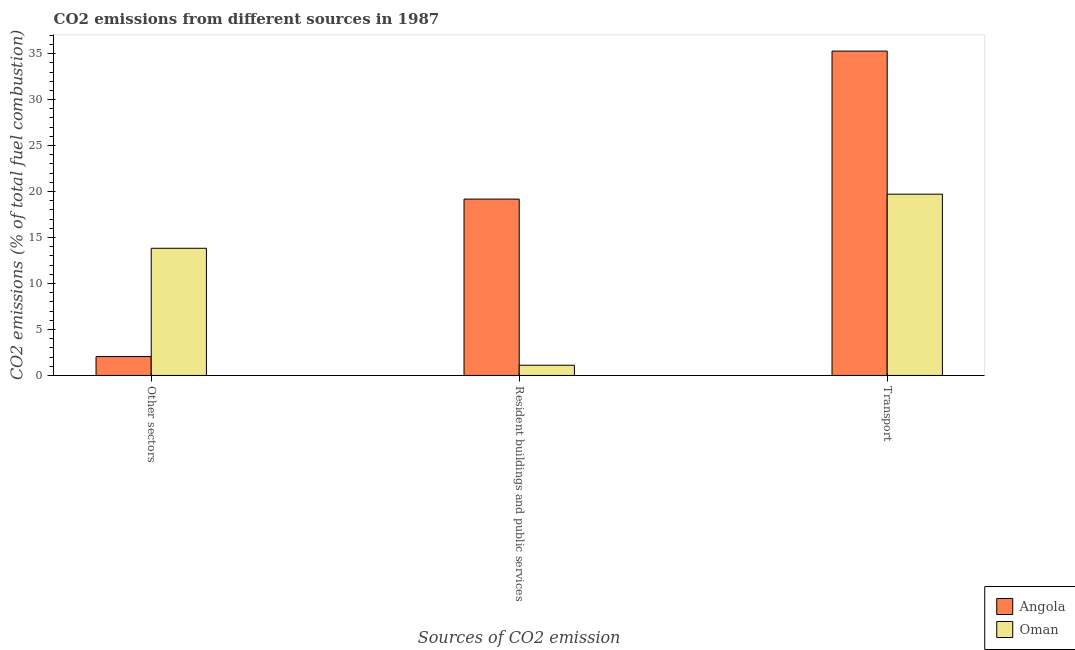How many different coloured bars are there?
Provide a succinct answer. 2. How many groups of bars are there?
Your response must be concise. 3. Are the number of bars on each tick of the X-axis equal?
Make the answer very short. Yes. What is the label of the 1st group of bars from the left?
Provide a succinct answer. Other sectors. What is the percentage of co2 emissions from resident buildings and public services in Angola?
Provide a succinct answer. 19.18. Across all countries, what is the maximum percentage of co2 emissions from transport?
Give a very brief answer. 35.27. Across all countries, what is the minimum percentage of co2 emissions from resident buildings and public services?
Your answer should be very brief. 1.11. In which country was the percentage of co2 emissions from resident buildings and public services maximum?
Ensure brevity in your answer.  Angola. In which country was the percentage of co2 emissions from other sectors minimum?
Your response must be concise. Angola. What is the total percentage of co2 emissions from other sectors in the graph?
Offer a terse response. 15.89. What is the difference between the percentage of co2 emissions from other sectors in Oman and that in Angola?
Keep it short and to the point. 11.78. What is the difference between the percentage of co2 emissions from other sectors in Angola and the percentage of co2 emissions from resident buildings and public services in Oman?
Give a very brief answer. 0.94. What is the average percentage of co2 emissions from transport per country?
Give a very brief answer. 27.49. What is the difference between the percentage of co2 emissions from transport and percentage of co2 emissions from other sectors in Oman?
Your answer should be compact. 5.88. In how many countries, is the percentage of co2 emissions from other sectors greater than 15 %?
Your answer should be very brief. 0. What is the ratio of the percentage of co2 emissions from resident buildings and public services in Oman to that in Angola?
Give a very brief answer. 0.06. What is the difference between the highest and the second highest percentage of co2 emissions from resident buildings and public services?
Provide a succinct answer. 18.07. What is the difference between the highest and the lowest percentage of co2 emissions from transport?
Ensure brevity in your answer.  15.56. What does the 2nd bar from the left in Resident buildings and public services represents?
Provide a short and direct response. Oman. What does the 2nd bar from the right in Transport represents?
Ensure brevity in your answer.  Angola. What is the difference between two consecutive major ticks on the Y-axis?
Give a very brief answer. 5. Are the values on the major ticks of Y-axis written in scientific E-notation?
Provide a succinct answer. No. How many legend labels are there?
Keep it short and to the point. 2. What is the title of the graph?
Provide a succinct answer. CO2 emissions from different sources in 1987. What is the label or title of the X-axis?
Your answer should be very brief. Sources of CO2 emission. What is the label or title of the Y-axis?
Your answer should be very brief. CO2 emissions (% of total fuel combustion). What is the CO2 emissions (% of total fuel combustion) in Angola in Other sectors?
Make the answer very short. 2.05. What is the CO2 emissions (% of total fuel combustion) in Oman in Other sectors?
Keep it short and to the point. 13.83. What is the CO2 emissions (% of total fuel combustion) in Angola in Resident buildings and public services?
Make the answer very short. 19.18. What is the CO2 emissions (% of total fuel combustion) in Oman in Resident buildings and public services?
Provide a succinct answer. 1.11. What is the CO2 emissions (% of total fuel combustion) in Angola in Transport?
Offer a terse response. 35.27. What is the CO2 emissions (% of total fuel combustion) in Oman in Transport?
Your response must be concise. 19.71. Across all Sources of CO2 emission, what is the maximum CO2 emissions (% of total fuel combustion) of Angola?
Give a very brief answer. 35.27. Across all Sources of CO2 emission, what is the maximum CO2 emissions (% of total fuel combustion) of Oman?
Keep it short and to the point. 19.71. Across all Sources of CO2 emission, what is the minimum CO2 emissions (% of total fuel combustion) in Angola?
Offer a very short reply. 2.05. Across all Sources of CO2 emission, what is the minimum CO2 emissions (% of total fuel combustion) of Oman?
Provide a succinct answer. 1.11. What is the total CO2 emissions (% of total fuel combustion) of Angola in the graph?
Keep it short and to the point. 56.51. What is the total CO2 emissions (% of total fuel combustion) in Oman in the graph?
Your response must be concise. 34.66. What is the difference between the CO2 emissions (% of total fuel combustion) in Angola in Other sectors and that in Resident buildings and public services?
Give a very brief answer. -17.12. What is the difference between the CO2 emissions (% of total fuel combustion) in Oman in Other sectors and that in Resident buildings and public services?
Provide a succinct answer. 12.72. What is the difference between the CO2 emissions (% of total fuel combustion) of Angola in Other sectors and that in Transport?
Your response must be concise. -33.22. What is the difference between the CO2 emissions (% of total fuel combustion) in Oman in Other sectors and that in Transport?
Make the answer very short. -5.88. What is the difference between the CO2 emissions (% of total fuel combustion) in Angola in Resident buildings and public services and that in Transport?
Offer a terse response. -16.1. What is the difference between the CO2 emissions (% of total fuel combustion) in Oman in Resident buildings and public services and that in Transport?
Your answer should be compact. -18.6. What is the difference between the CO2 emissions (% of total fuel combustion) in Angola in Other sectors and the CO2 emissions (% of total fuel combustion) in Oman in Resident buildings and public services?
Your answer should be very brief. 0.94. What is the difference between the CO2 emissions (% of total fuel combustion) of Angola in Other sectors and the CO2 emissions (% of total fuel combustion) of Oman in Transport?
Your answer should be very brief. -17.66. What is the difference between the CO2 emissions (% of total fuel combustion) of Angola in Resident buildings and public services and the CO2 emissions (% of total fuel combustion) of Oman in Transport?
Provide a succinct answer. -0.54. What is the average CO2 emissions (% of total fuel combustion) in Angola per Sources of CO2 emission?
Your answer should be compact. 18.84. What is the average CO2 emissions (% of total fuel combustion) in Oman per Sources of CO2 emission?
Offer a very short reply. 11.55. What is the difference between the CO2 emissions (% of total fuel combustion) of Angola and CO2 emissions (% of total fuel combustion) of Oman in Other sectors?
Ensure brevity in your answer.  -11.78. What is the difference between the CO2 emissions (% of total fuel combustion) in Angola and CO2 emissions (% of total fuel combustion) in Oman in Resident buildings and public services?
Keep it short and to the point. 18.07. What is the difference between the CO2 emissions (% of total fuel combustion) in Angola and CO2 emissions (% of total fuel combustion) in Oman in Transport?
Offer a very short reply. 15.56. What is the ratio of the CO2 emissions (% of total fuel combustion) in Angola in Other sectors to that in Resident buildings and public services?
Offer a terse response. 0.11. What is the ratio of the CO2 emissions (% of total fuel combustion) of Oman in Other sectors to that in Resident buildings and public services?
Your response must be concise. 12.43. What is the ratio of the CO2 emissions (% of total fuel combustion) of Angola in Other sectors to that in Transport?
Give a very brief answer. 0.06. What is the ratio of the CO2 emissions (% of total fuel combustion) of Oman in Other sectors to that in Transport?
Provide a succinct answer. 0.7. What is the ratio of the CO2 emissions (% of total fuel combustion) of Angola in Resident buildings and public services to that in Transport?
Ensure brevity in your answer.  0.54. What is the ratio of the CO2 emissions (% of total fuel combustion) in Oman in Resident buildings and public services to that in Transport?
Your response must be concise. 0.06. What is the difference between the highest and the second highest CO2 emissions (% of total fuel combustion) in Angola?
Keep it short and to the point. 16.1. What is the difference between the highest and the second highest CO2 emissions (% of total fuel combustion) in Oman?
Ensure brevity in your answer.  5.88. What is the difference between the highest and the lowest CO2 emissions (% of total fuel combustion) of Angola?
Offer a very short reply. 33.22. What is the difference between the highest and the lowest CO2 emissions (% of total fuel combustion) of Oman?
Provide a short and direct response. 18.6. 